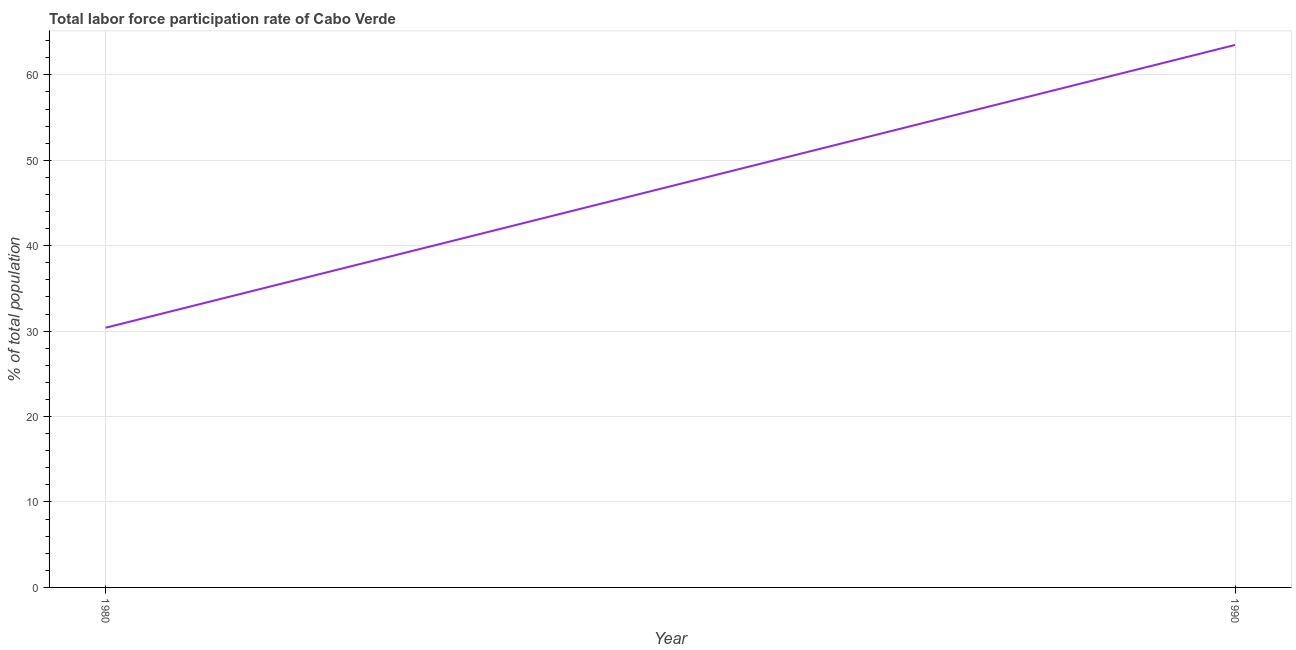What is the total labor force participation rate in 1980?
Provide a short and direct response. 30.4. Across all years, what is the maximum total labor force participation rate?
Ensure brevity in your answer.  63.5. Across all years, what is the minimum total labor force participation rate?
Make the answer very short. 30.4. In which year was the total labor force participation rate maximum?
Your response must be concise. 1990. What is the sum of the total labor force participation rate?
Your answer should be compact. 93.9. What is the difference between the total labor force participation rate in 1980 and 1990?
Provide a short and direct response. -33.1. What is the average total labor force participation rate per year?
Your answer should be very brief. 46.95. What is the median total labor force participation rate?
Provide a succinct answer. 46.95. Do a majority of the years between 1990 and 1980 (inclusive) have total labor force participation rate greater than 24 %?
Offer a terse response. No. What is the ratio of the total labor force participation rate in 1980 to that in 1990?
Offer a terse response. 0.48. Does the total labor force participation rate monotonically increase over the years?
Provide a short and direct response. Yes. Are the values on the major ticks of Y-axis written in scientific E-notation?
Your answer should be very brief. No. Does the graph contain grids?
Give a very brief answer. Yes. What is the title of the graph?
Provide a succinct answer. Total labor force participation rate of Cabo Verde. What is the label or title of the Y-axis?
Your answer should be compact. % of total population. What is the % of total population of 1980?
Your answer should be very brief. 30.4. What is the % of total population in 1990?
Offer a very short reply. 63.5. What is the difference between the % of total population in 1980 and 1990?
Provide a succinct answer. -33.1. What is the ratio of the % of total population in 1980 to that in 1990?
Provide a short and direct response. 0.48. 